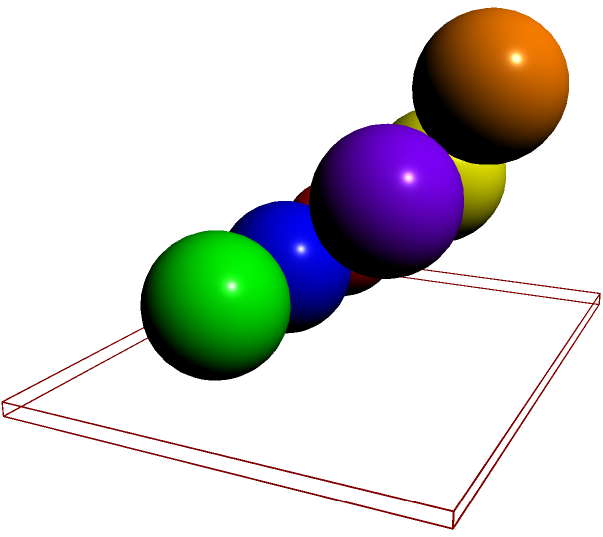On your desk, you've stacked 6 identical spherical stress balls as shown in the image. Each ball has a radius of 5 cm. What is the total volume of all the stress balls combined? Round your answer to the nearest cubic centimeter. To solve this problem, let's follow these steps:

1. Recall the formula for the volume of a sphere:
   $V = \frac{4}{3}\pi r^3$

2. We're given that each ball has a radius of 5 cm. Let's substitute this into our formula:
   $V = \frac{4}{3}\pi (5\text{ cm})^3$

3. Let's calculate this:
   $V = \frac{4}{3}\pi (125\text{ cm}^3)$
   $V = \frac{500\pi}{3}\text{ cm}^3$
   $V \approx 523.6\text{ cm}^3$

4. This is the volume of one stress ball. Since we have 6 identical balls, we need to multiply this result by 6:
   $\text{Total Volume} = 6 \times 523.6\text{ cm}^3 = 3141.6\text{ cm}^3$

5. Rounding to the nearest cubic centimeter:
   $\text{Total Volume} \approx 3142\text{ cm}^3$
Answer: 3142 cm³ 